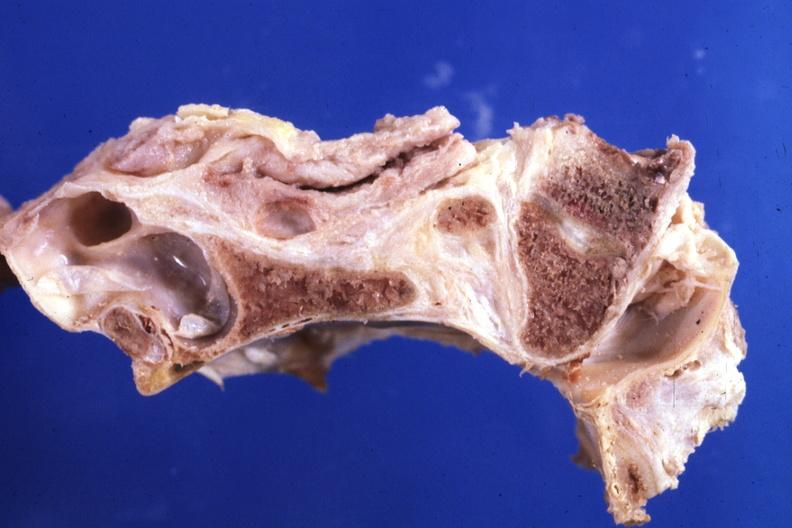what is present?
Answer the question using a single word or phrase. Bone, calvarium 